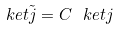Convert formula to latex. <formula><loc_0><loc_0><loc_500><loc_500>\ k e t { \tilde { j } } = C \ k e t { j }</formula> 